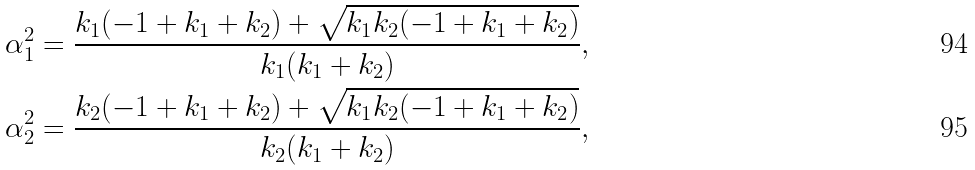<formula> <loc_0><loc_0><loc_500><loc_500>\alpha _ { 1 } ^ { 2 } & = \frac { k _ { 1 } ( - 1 + k _ { 1 } + k _ { 2 } ) + \sqrt { k _ { 1 } k _ { 2 } ( - 1 + k _ { 1 } + k _ { 2 } ) } } { k _ { 1 } ( k _ { 1 } + k _ { 2 } ) } , \\ \alpha _ { 2 } ^ { 2 } & = \frac { k _ { 2 } ( - 1 + k _ { 1 } + k _ { 2 } ) + \sqrt { k _ { 1 } k _ { 2 } ( - 1 + k _ { 1 } + k _ { 2 } ) } } { k _ { 2 } ( k _ { 1 } + k _ { 2 } ) } ,</formula> 